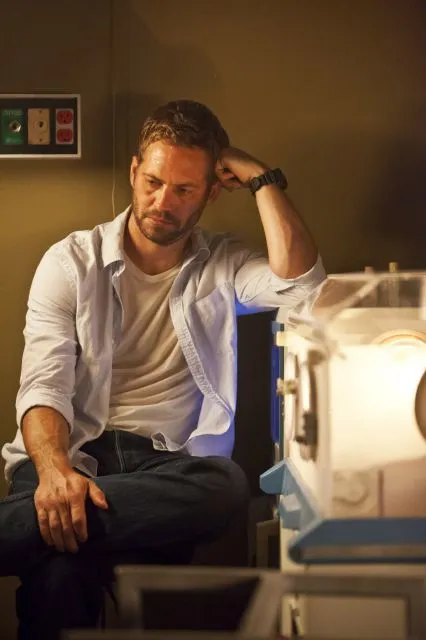What's happening in the scene? In the image, we see a man who appears to be in a thoughtful or contemplative pose. He is seated on a desk within what looks like a laboratory setting. His left hand is resting on his head, and his right hand is on his knee. He is dressed in a white button-down shirt layered over a white t-shirt and blue jeans. The laboratory behind him is filled with various pieces of equipment, including an incubator or specialized machine to his right. The man is focused, indicating he might be deep in thought about something serious or important. 